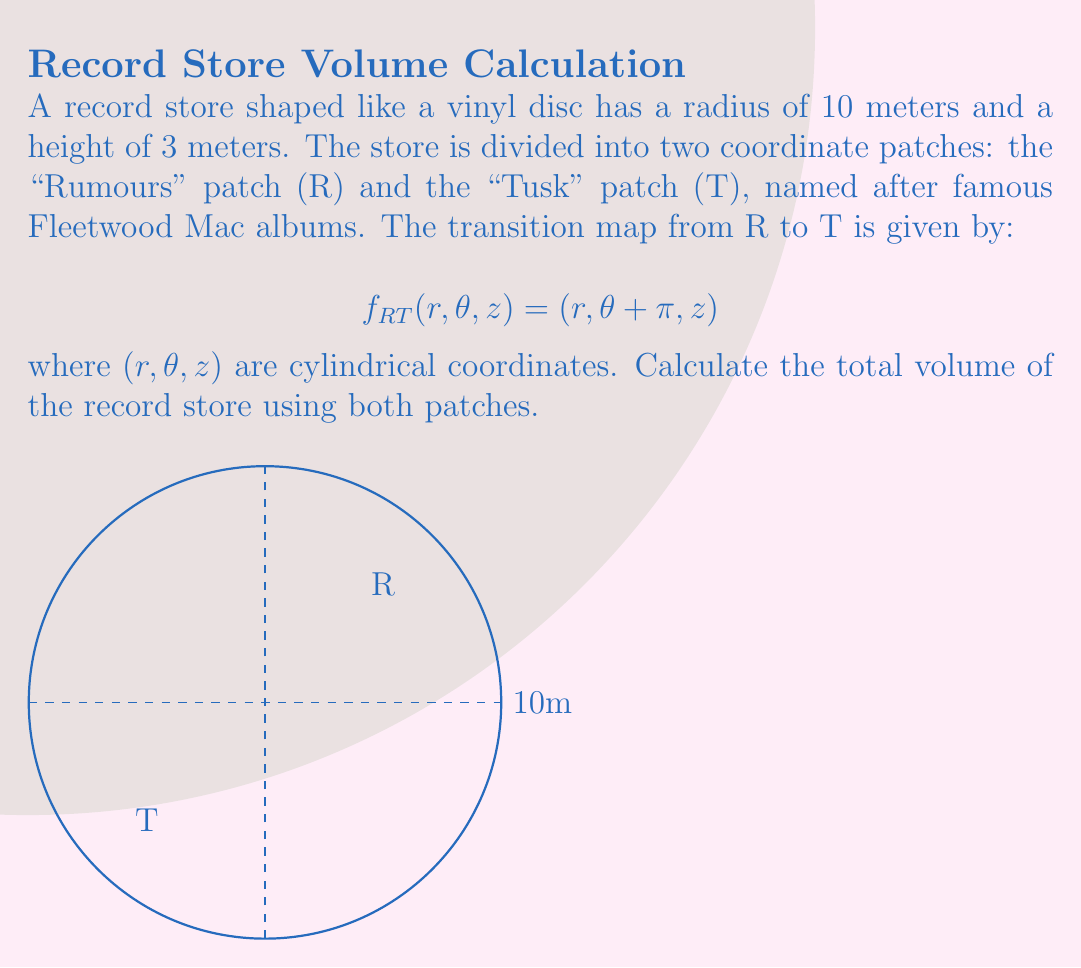Give your solution to this math problem. Let's approach this step-by-step:

1) First, we need to understand what the coordinate patches and transition map mean:
   - The store is divided into two halves: R and T
   - The transition map $f_{RT}$ shows how coordinates in R relate to coordinates in T

2) The volume of a cylinder in cylindrical coordinates is given by:

   $$V = \int_0^{2\pi} \int_0^R \int_0^H r \, dz \, dr \, d\theta$$

   where R is the radius and H is the height.

3) For our record store:
   R = 10 meters
   H = 3 meters

4) We can calculate the volume using either patch R or T, or both. Let's use both to demonstrate the use of multiple patches:

   For patch R (0 to π):
   $$V_R = \int_0^{\pi} \int_0^{10} \int_0^3 r \, dz \, dr \, d\theta$$

   For patch T (π to 2π):
   $$V_T = \int_{\pi}^{2\pi} \int_0^{10} \int_0^3 r \, dz \, dr \, d\theta$$

5) Solving these integrals:

   $$V_R = V_T = \frac{1}{2} \pi \cdot 10^2 \cdot 3 = 150\pi$$

6) The total volume is the sum of volumes from both patches:

   $$V_{total} = V_R + V_T = 150\pi + 150\pi = 300\pi$$

7) Therefore, the volume of the record store is $300\pi$ cubic meters.

Note: The transition map doesn't affect the volume calculation in this case because the store's shape is symmetric and we're covering the entire space with the two patches.
Answer: $300\pi$ cubic meters 